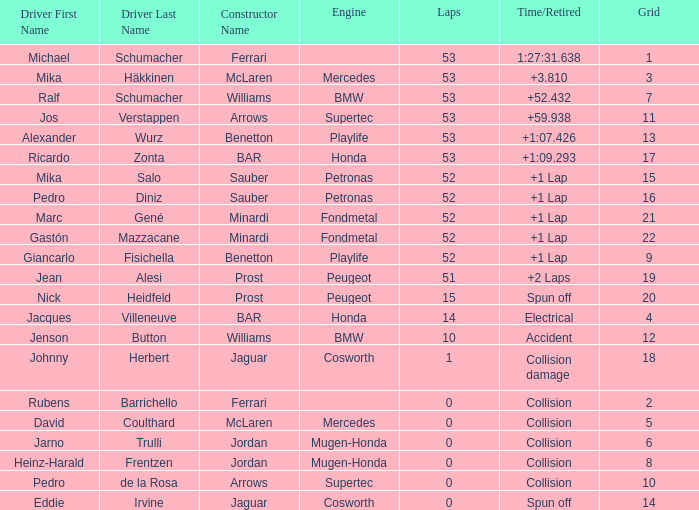What is the grid number with less than 52 laps and a Time/Retired of collision, and a Constructor of arrows - supertec? 1.0. 